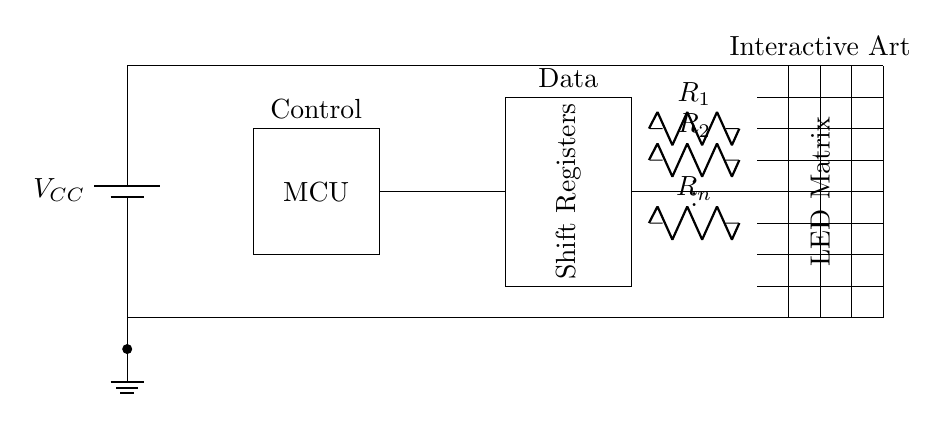What is the MCU's role in this circuit? The Microcontroller Unit (MCU) is responsible for controlling the LED matrix, managing the data flow, and generating the necessary signals to create the desired visual output. It acts as the brain of the circuit.
Answer: Control What are the main components of this circuit? The key components in this circuit include a battery for power supply, a microcontroller, shift registers for data handling, an LED matrix as the output display, and current limiting resistors to prevent damage to the LEDs.
Answer: Battery, MCU, Shift Registers, LED Matrix, Resistors How many resistors are used in this circuit? The circuit includes an unspecified number of current limiting resistors labeled from R1 to Rn, suggesting there could be multiple resistors connected to the LED matrix rows or columns. The specific number, n, is not indicated.
Answer: n What purpose do the shift registers serve? Shift registers are used to convert the serial data from the microcontroller into parallel data to control the columns or rows of the LED matrix, allowing for complex patterns and animations.
Answer: Data handling What is the significance of the ground connection? The ground connection is essential as it provides a common reference point for the circuit. It ensures that all components operate at the same voltage level and allows for a return path for current, which is crucial for the circuit's functionality.
Answer: Common reference What could happen if the current limiting resistors were omitted? If the current limiting resistors were omitted, the LEDs could draw too much current, leading to overheating and potential damage. This could cause immediate failure of the LEDs or significantly reduce their lifespan.
Answer: Damage to LEDs What does the grid represent in the circuit? The grid represents the LED matrix itself, which is the area where individual LEDs are arranged in a two-dimensional array for visual display. Each point in the grid can light up to create patterns.
Answer: LED Matrix 